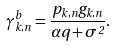<formula> <loc_0><loc_0><loc_500><loc_500>\gamma _ { k , n } ^ { b } = \frac { { { p _ { k , n } } { g _ { k , n } } } } { { \alpha q + { \sigma ^ { 2 } } } } .</formula> 